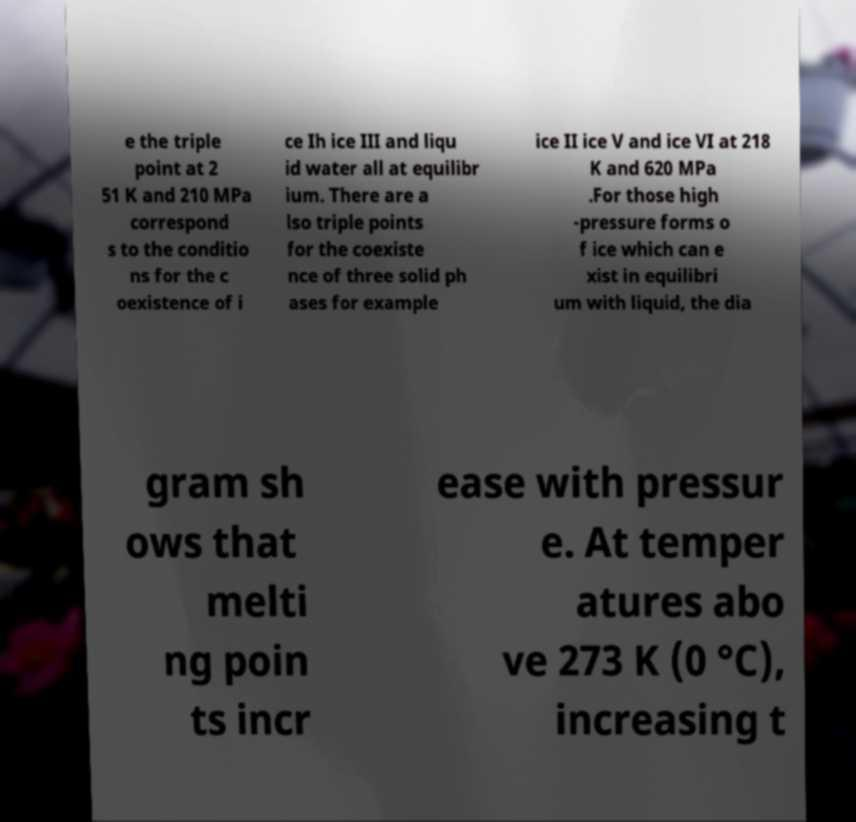Can you read and provide the text displayed in the image?This photo seems to have some interesting text. Can you extract and type it out for me? e the triple point at 2 51 K and 210 MPa correspond s to the conditio ns for the c oexistence of i ce Ih ice III and liqu id water all at equilibr ium. There are a lso triple points for the coexiste nce of three solid ph ases for example ice II ice V and ice VI at 218 K and 620 MPa .For those high -pressure forms o f ice which can e xist in equilibri um with liquid, the dia gram sh ows that melti ng poin ts incr ease with pressur e. At temper atures abo ve 273 K (0 °C), increasing t 